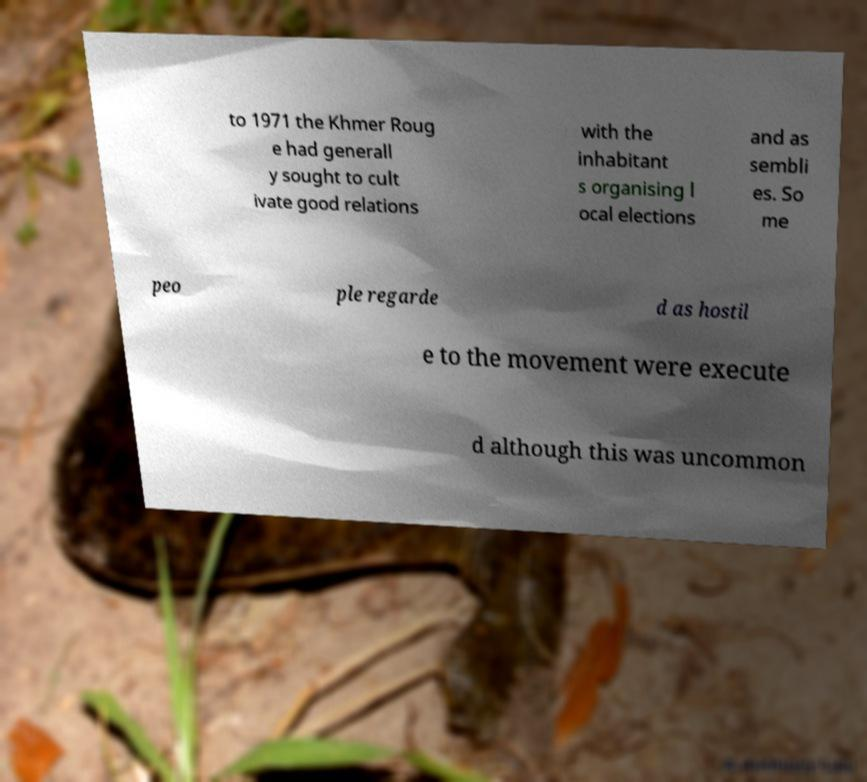Can you read and provide the text displayed in the image?This photo seems to have some interesting text. Can you extract and type it out for me? to 1971 the Khmer Roug e had generall y sought to cult ivate good relations with the inhabitant s organising l ocal elections and as sembli es. So me peo ple regarde d as hostil e to the movement were execute d although this was uncommon 